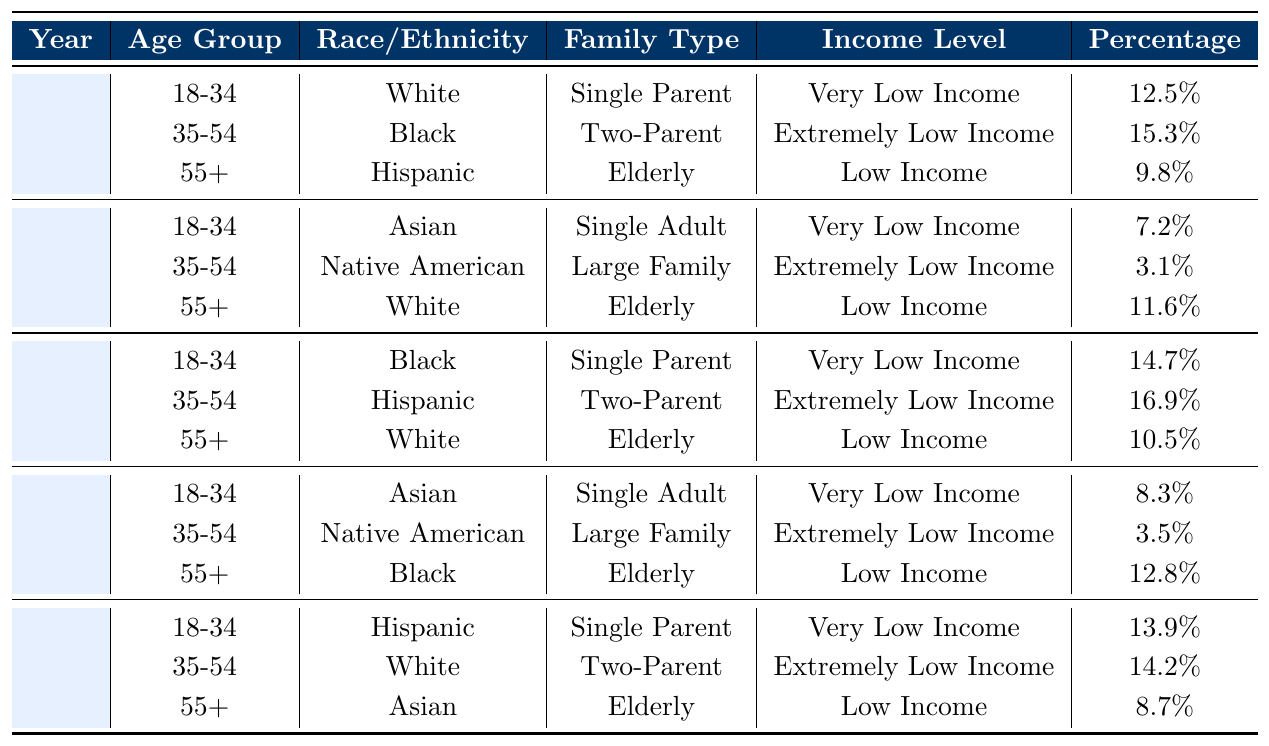What was the percentage of Hispanic elderly recipients in 2020? In 2020, the table shows that there were 3 records for the age group 55+ with race/ethnicity Hispanic. The percentage for this group is 10.5%, which is indicated alongside their family type (Elderly) and income level (Low Income).
Answer: 10.5% Which age group had the highest percentage of Very Low Income recipients in 2021? By looking at the row for the year 2021, the age group 18-34 had a Very Low Income recipient percentage of 8.3%. This is higher compared to the 35-54 age group at 3.5%. Therefore, the age group with the highest percentage is 18-34.
Answer: 18-34 What is the percentage difference of Black recipients in the age group 18-34 between 2020 and 2021? In 2020, the percentage of Black recipients aged 18-34 was 14.7%. In 2021, this percentage decreased to 8.3%. The difference in these percentages is calculated as 14.7% - 8.3% = 6.4%.
Answer: 6.4% Did any year have a higher percentage of Asian elderly recipients compared to 2022? In 2022, the percentage for Asian elderly recipients is 8.7%. In the previous years, there are no entries for Asians within the 55+ age group. Thus, the only comparison is with the entry in 2022. Therefore, it can be concluded that 2022 is the only year with Asian elderly recorded.
Answer: No What was the overall percentage of Very Low Income recipients across all years in the 18-34 age group? Summing up the percentages from each year for the 18-34 age group, we get 12.5% (2018) + 7.2% (2019) + 14.7% (2020) + 8.3% (2021) + 13.9% (2022) = 56.6%. To find the average, we divide this sum (56.6%) by the number of years (5), yielding 11.32%.
Answer: 11.32% How many race/ethnic categories are represented in the Single Parent family type across the years? In the table, the Single Parent family type appears for White in 2018, Black in 2020, and Hispanic in 2022. Thus, there are three distinct race/ethnic categories represented in the Single Parent family type.
Answer: 3 